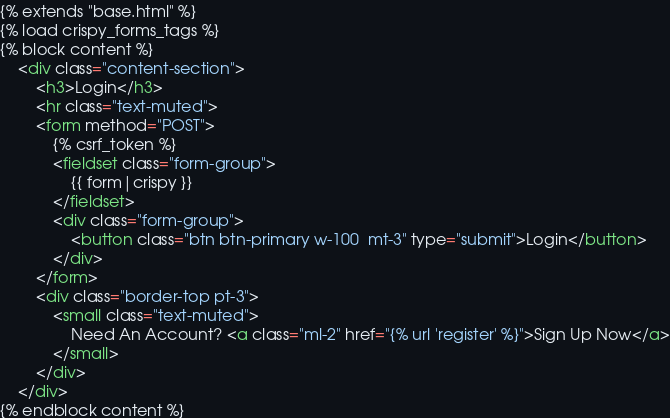<code> <loc_0><loc_0><loc_500><loc_500><_HTML_>{% extends "base.html" %}
{% load crispy_forms_tags %}
{% block content %}
    <div class="content-section">
        <h3>Login</h3>
        <hr class="text-muted">
        <form method="POST">
            {% csrf_token %}
            <fieldset class="form-group">
                {{ form|crispy }}
            </fieldset>
            <div class="form-group">
                <button class="btn btn-primary w-100  mt-3" type="submit">Login</button>
            </div>
        </form>
        <div class="border-top pt-3">
            <small class="text-muted">
                Need An Account? <a class="ml-2" href="{% url 'register' %}">Sign Up Now</a>
            </small>
        </div>
    </div>
{% endblock content %}</code> 